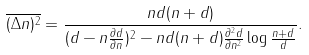Convert formula to latex. <formula><loc_0><loc_0><loc_500><loc_500>\overline { ( \Delta n ) ^ { 2 } } = \frac { n d ( n + d ) } { ( d - n \frac { \partial d } { \partial n } ) ^ { 2 } - n d ( n + d ) \frac { \partial ^ { 2 } d } { \partial n ^ { 2 } } \log \frac { n + d } { d } } .</formula> 